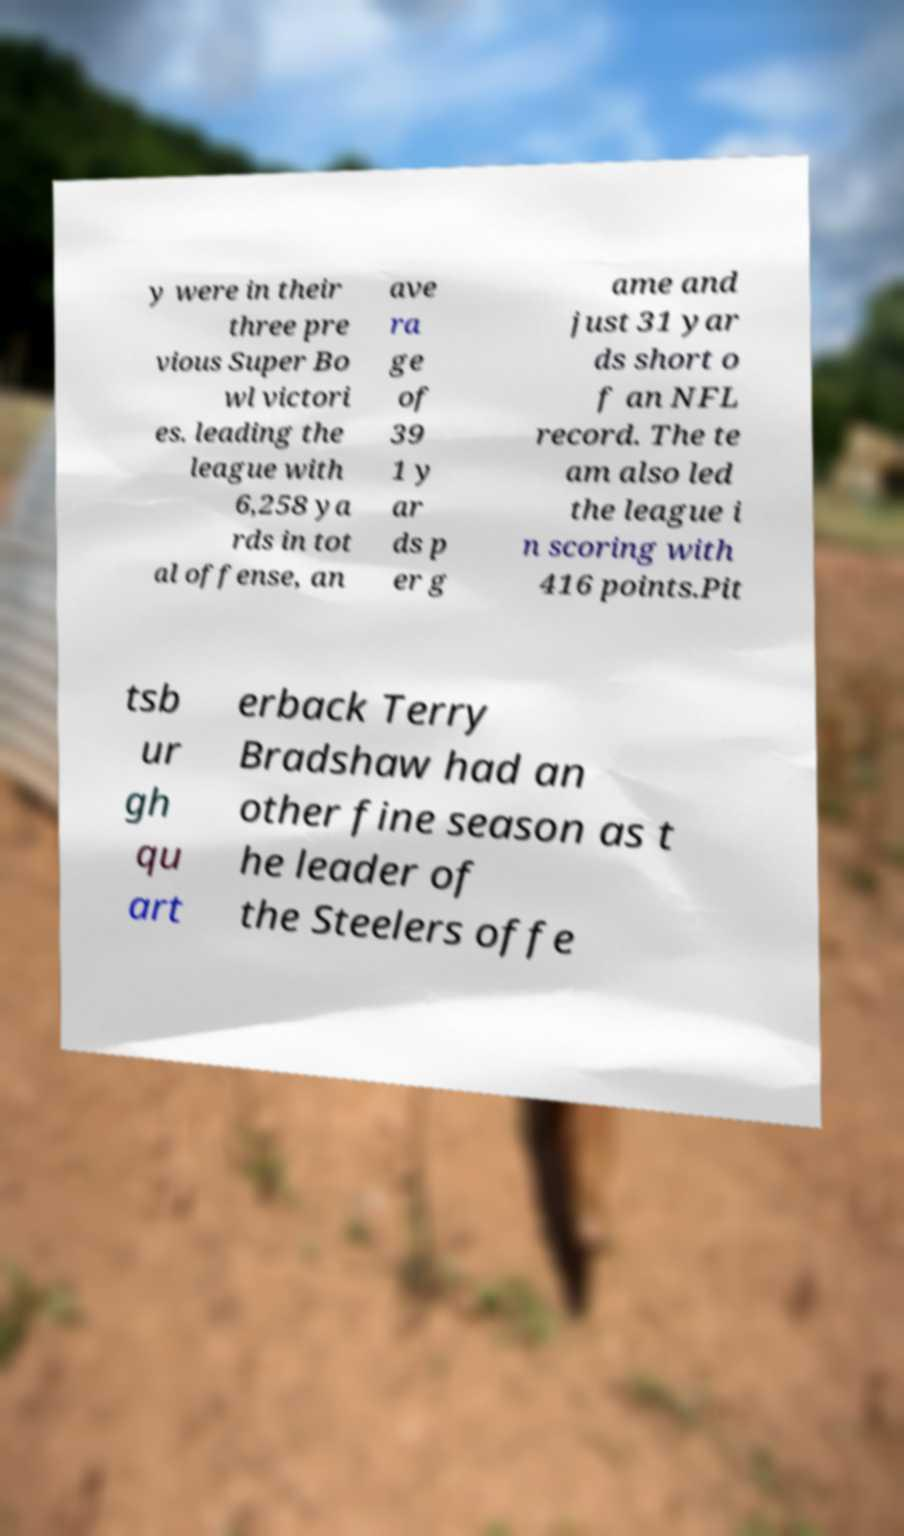Please identify and transcribe the text found in this image. y were in their three pre vious Super Bo wl victori es. leading the league with 6,258 ya rds in tot al offense, an ave ra ge of 39 1 y ar ds p er g ame and just 31 yar ds short o f an NFL record. The te am also led the league i n scoring with 416 points.Pit tsb ur gh qu art erback Terry Bradshaw had an other fine season as t he leader of the Steelers offe 